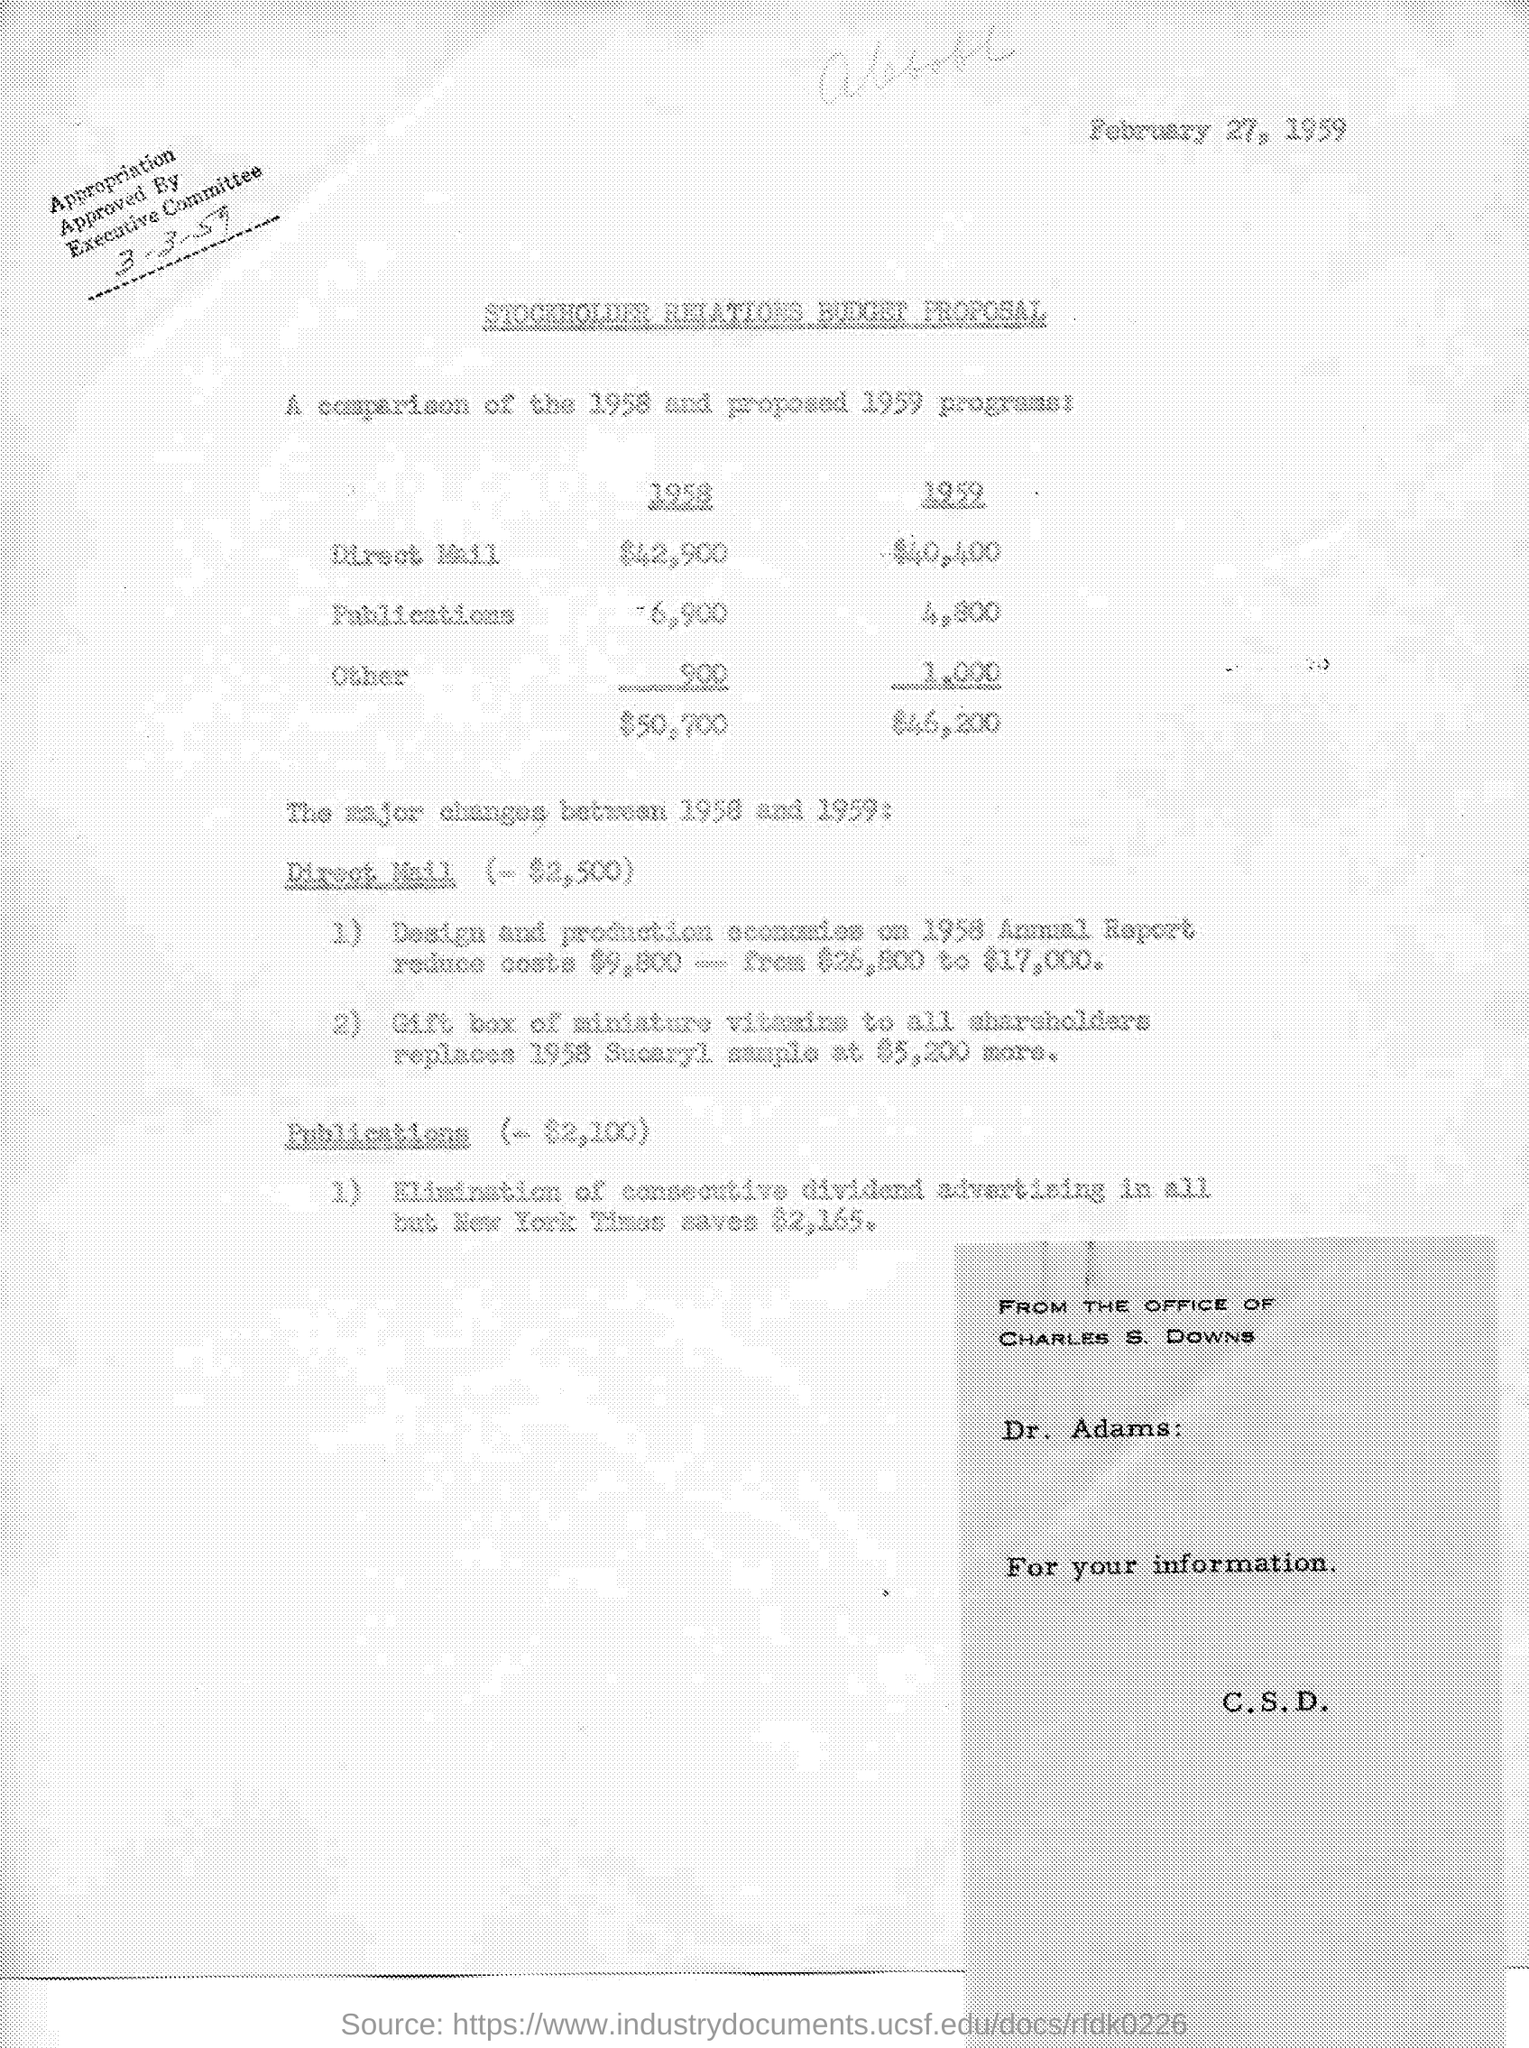What is the budget for direct mail in the year 1958 ?
Offer a very short reply. $ 42,900. What is the budget of publications in the year 1958 ?
Offer a terse response. -6,900. What is the budget for publications in the year 1959 ?
Keep it short and to the point. 4,800. What is the budget for others in the year 1958 ?
Offer a very short reply. 900. What is the budget for others in the year 1959 ?
Your response must be concise. 1,000. What is the amount of total budget in the year 1958 ?
Provide a succinct answer. $50,700. What is the amount of total budget in the year 1959 ?
Your answer should be very brief. $ 46,200. What is the date mentioned in the given page ?
Your response must be concise. February 27, 1959. By whom the appropriation was approved ?
Provide a short and direct response. Executive committee. 